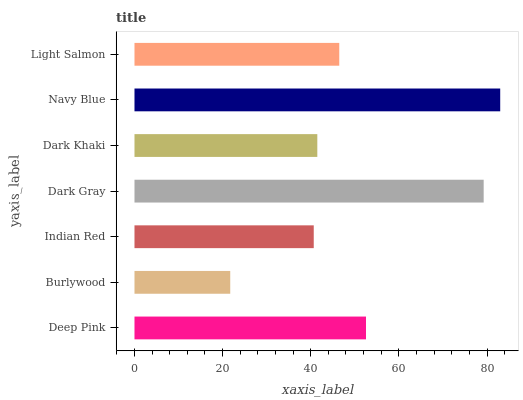Is Burlywood the minimum?
Answer yes or no. Yes. Is Navy Blue the maximum?
Answer yes or no. Yes. Is Indian Red the minimum?
Answer yes or no. No. Is Indian Red the maximum?
Answer yes or no. No. Is Indian Red greater than Burlywood?
Answer yes or no. Yes. Is Burlywood less than Indian Red?
Answer yes or no. Yes. Is Burlywood greater than Indian Red?
Answer yes or no. No. Is Indian Red less than Burlywood?
Answer yes or no. No. Is Light Salmon the high median?
Answer yes or no. Yes. Is Light Salmon the low median?
Answer yes or no. Yes. Is Indian Red the high median?
Answer yes or no. No. Is Deep Pink the low median?
Answer yes or no. No. 